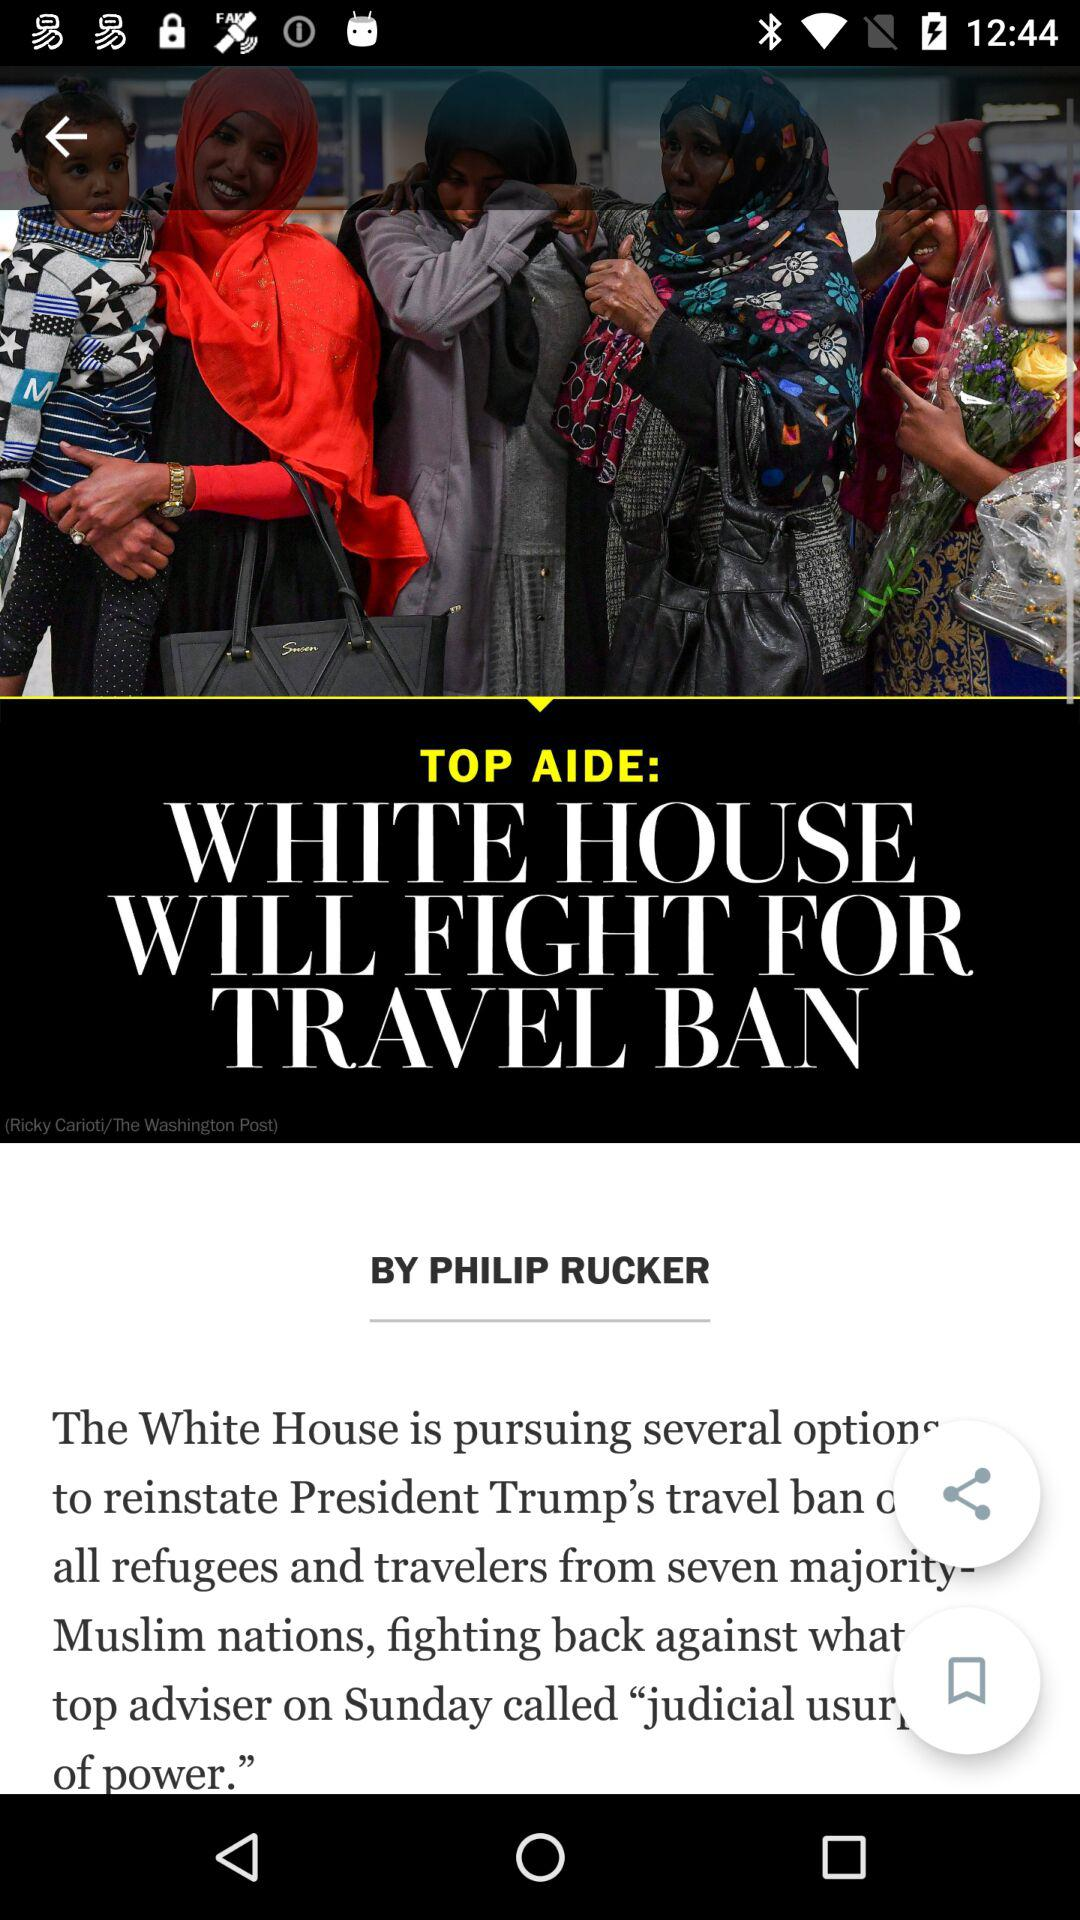What is the name of the article's author? The name of the article's author is Philip Rucker. 